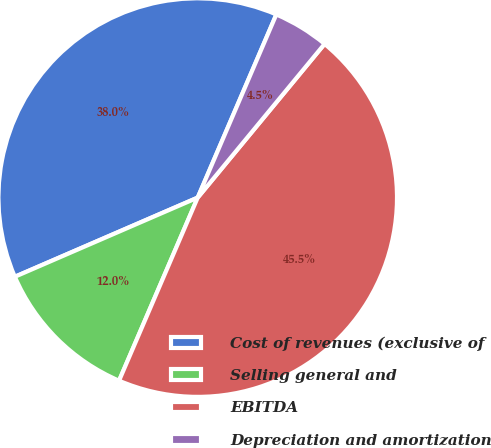<chart> <loc_0><loc_0><loc_500><loc_500><pie_chart><fcel>Cost of revenues (exclusive of<fcel>Selling general and<fcel>EBITDA<fcel>Depreciation and amortization<nl><fcel>37.96%<fcel>12.04%<fcel>45.48%<fcel>4.53%<nl></chart> 